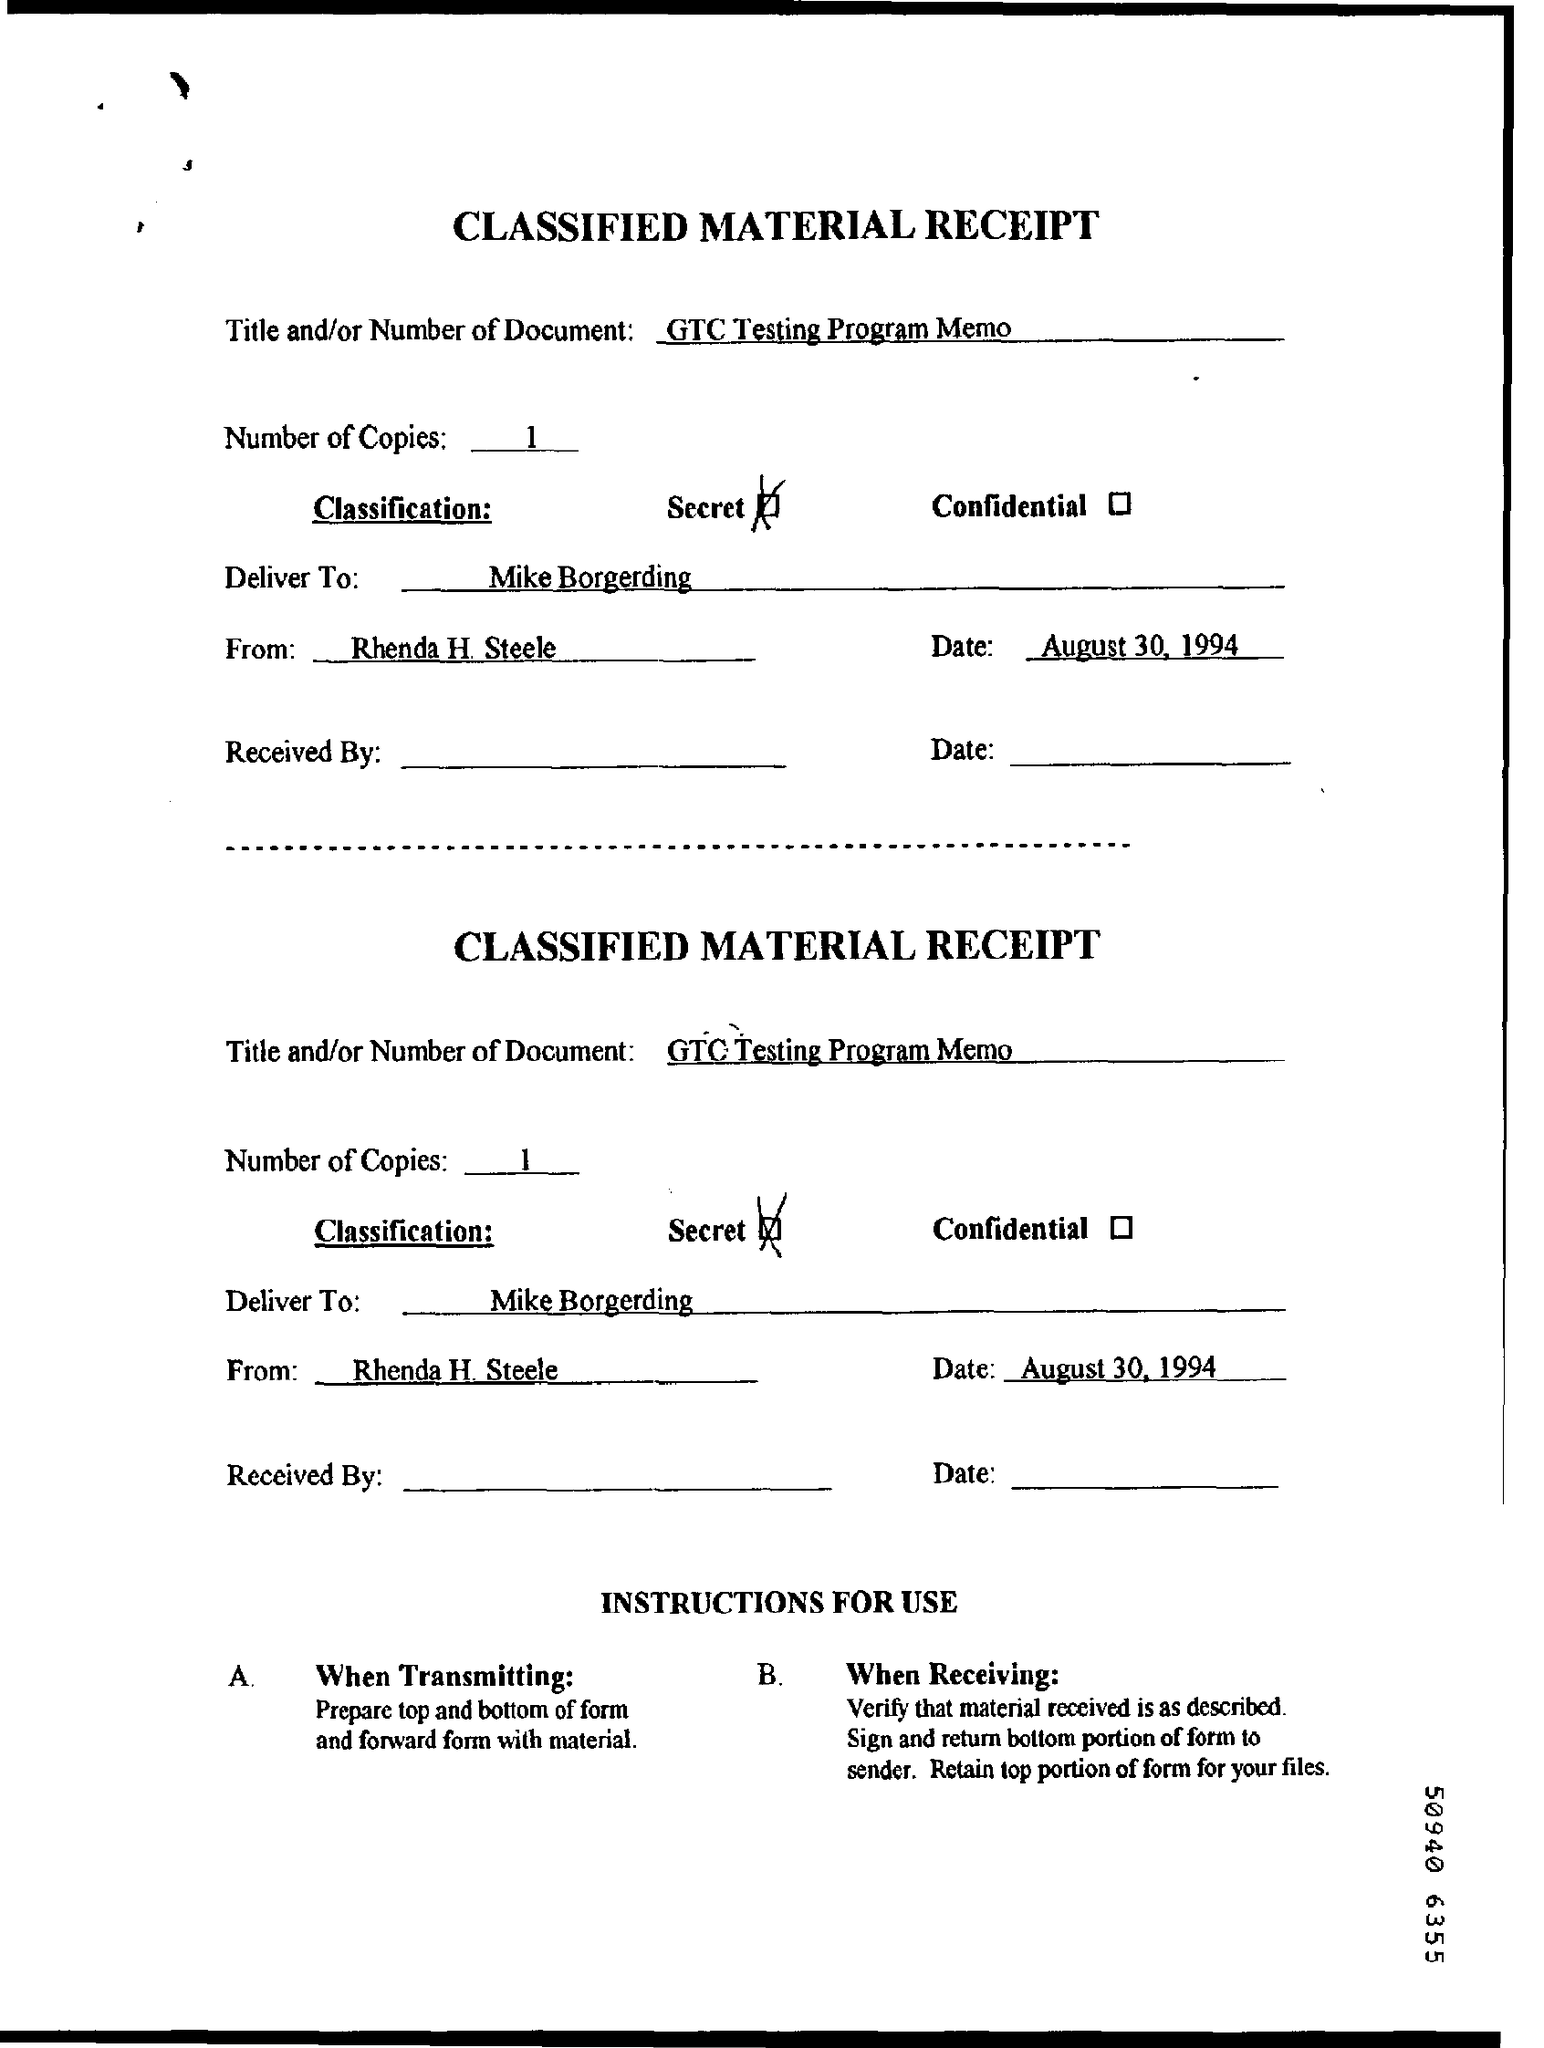How many Copies are there ?
Provide a short and direct response. 1. When is the Memorandum dated on ?
Offer a very short reply. August 30, 1994. Who is the Memorandum addressed to ?
Give a very brief answer. Mike Borgerding. Who is the Memorandum from ?
Give a very brief answer. Rhenda H Steele. 